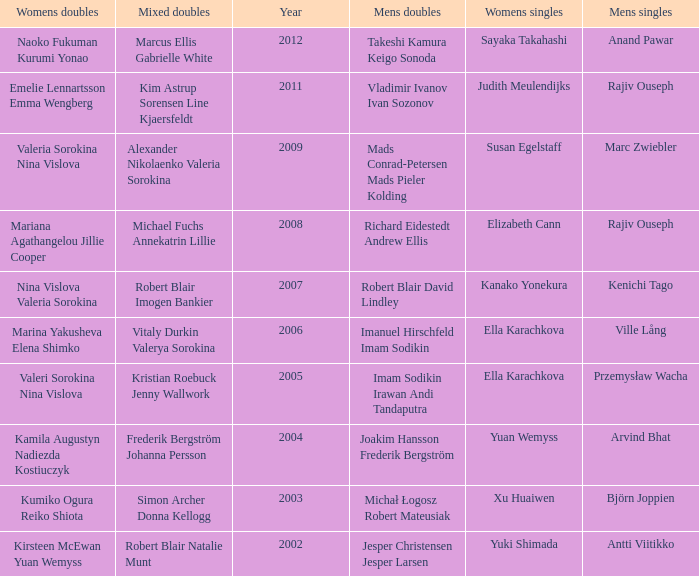Name the men's singles of marina yakusheva elena shimko Ville Lång. 